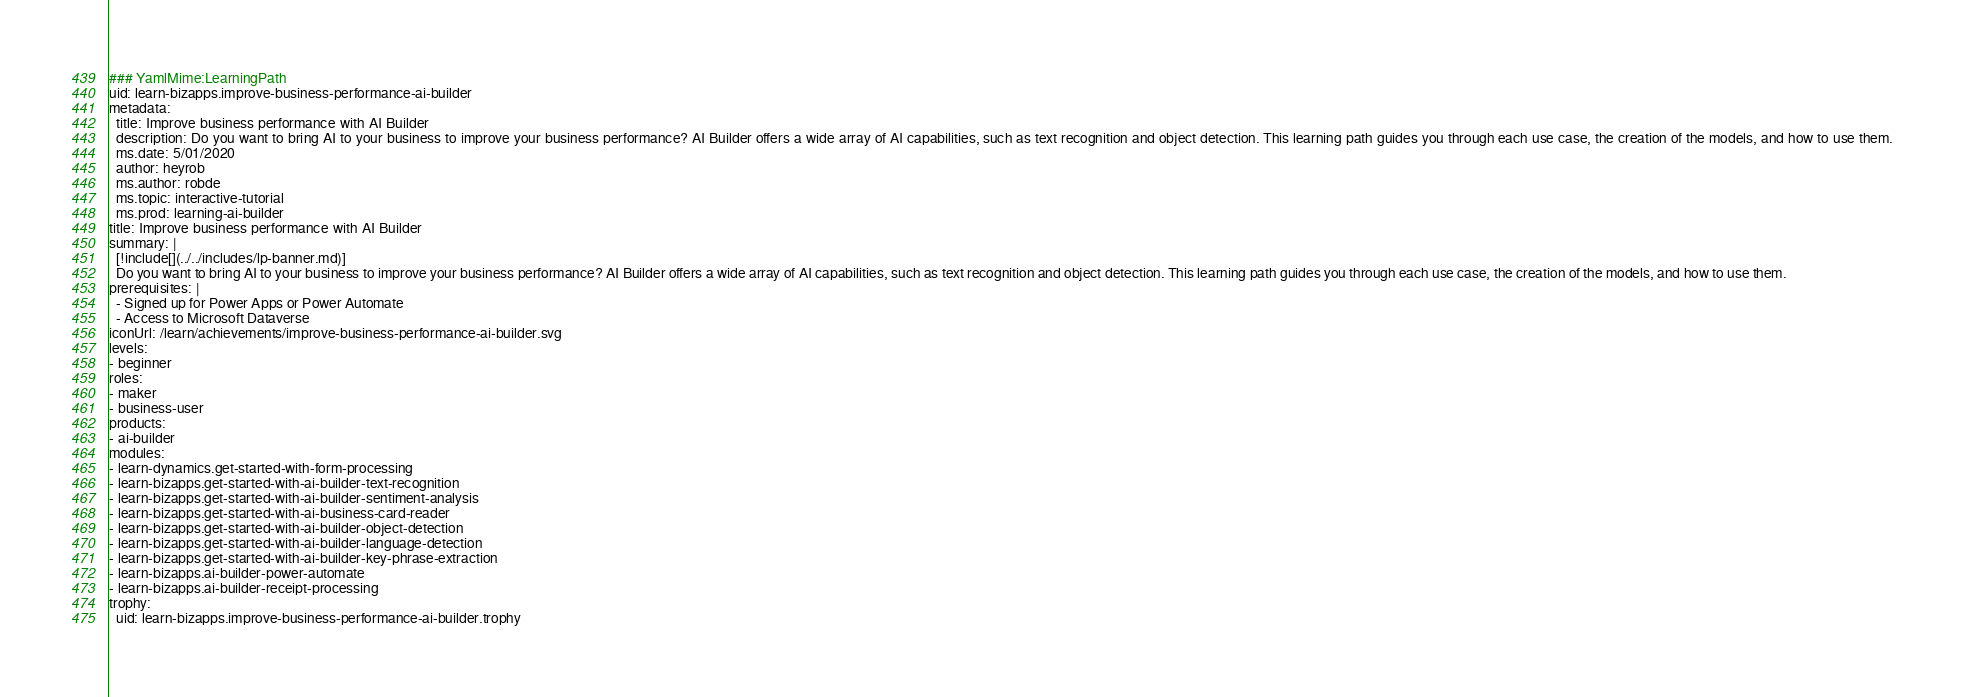<code> <loc_0><loc_0><loc_500><loc_500><_YAML_>### YamlMime:LearningPath
uid: learn-bizapps.improve-business-performance-ai-builder
metadata:
  title: Improve business performance with AI Builder
  description: Do you want to bring AI to your business to improve your business performance? AI Builder offers a wide array of AI capabilities, such as text recognition and object detection. This learning path guides you through each use case, the creation of the models, and how to use them.
  ms.date: 5/01/2020
  author: heyrob
  ms.author: robde
  ms.topic: interactive-tutorial
  ms.prod: learning-ai-builder
title: Improve business performance with AI Builder
summary: |
  [!include[](../../includes/lp-banner.md)]
  Do you want to bring AI to your business to improve your business performance? AI Builder offers a wide array of AI capabilities, such as text recognition and object detection. This learning path guides you through each use case, the creation of the models, and how to use them.
prerequisites: |
  - Signed up for Power Apps or Power Automate
  - Access to Microsoft Dataverse
iconUrl: /learn/achievements/improve-business-performance-ai-builder.svg
levels:
- beginner
roles: 
- maker
- business-user
products:
- ai-builder
modules:
- learn-dynamics.get-started-with-form-processing
- learn-bizapps.get-started-with-ai-builder-text-recognition
- learn-bizapps.get-started-with-ai-builder-sentiment-analysis
- learn-bizapps.get-started-with-ai-business-card-reader
- learn-bizapps.get-started-with-ai-builder-object-detection
- learn-bizapps.get-started-with-ai-builder-language-detection
- learn-bizapps.get-started-with-ai-builder-key-phrase-extraction
- learn-bizapps.ai-builder-power-automate
- learn-bizapps.ai-builder-receipt-processing
trophy: 
  uid: learn-bizapps.improve-business-performance-ai-builder.trophy
</code> 